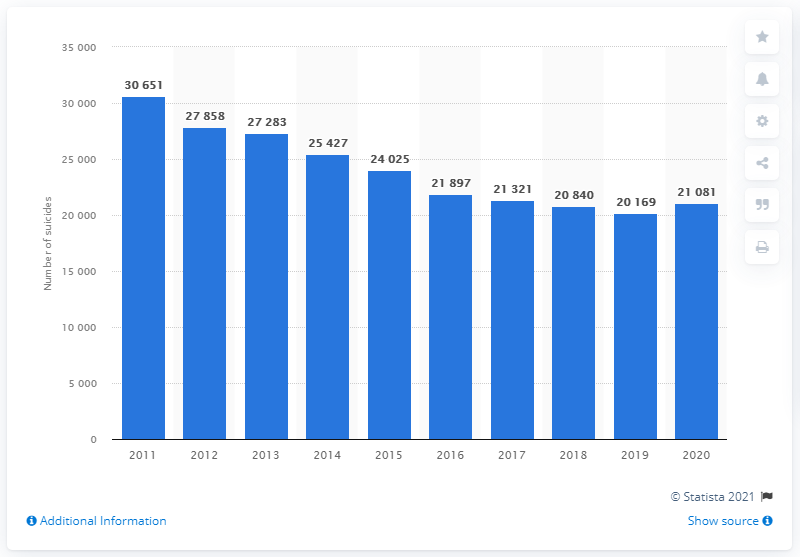List a handful of essential elements in this visual. It is reported that in 2020, a total of 21,081 individuals in Japan committed suicide. 